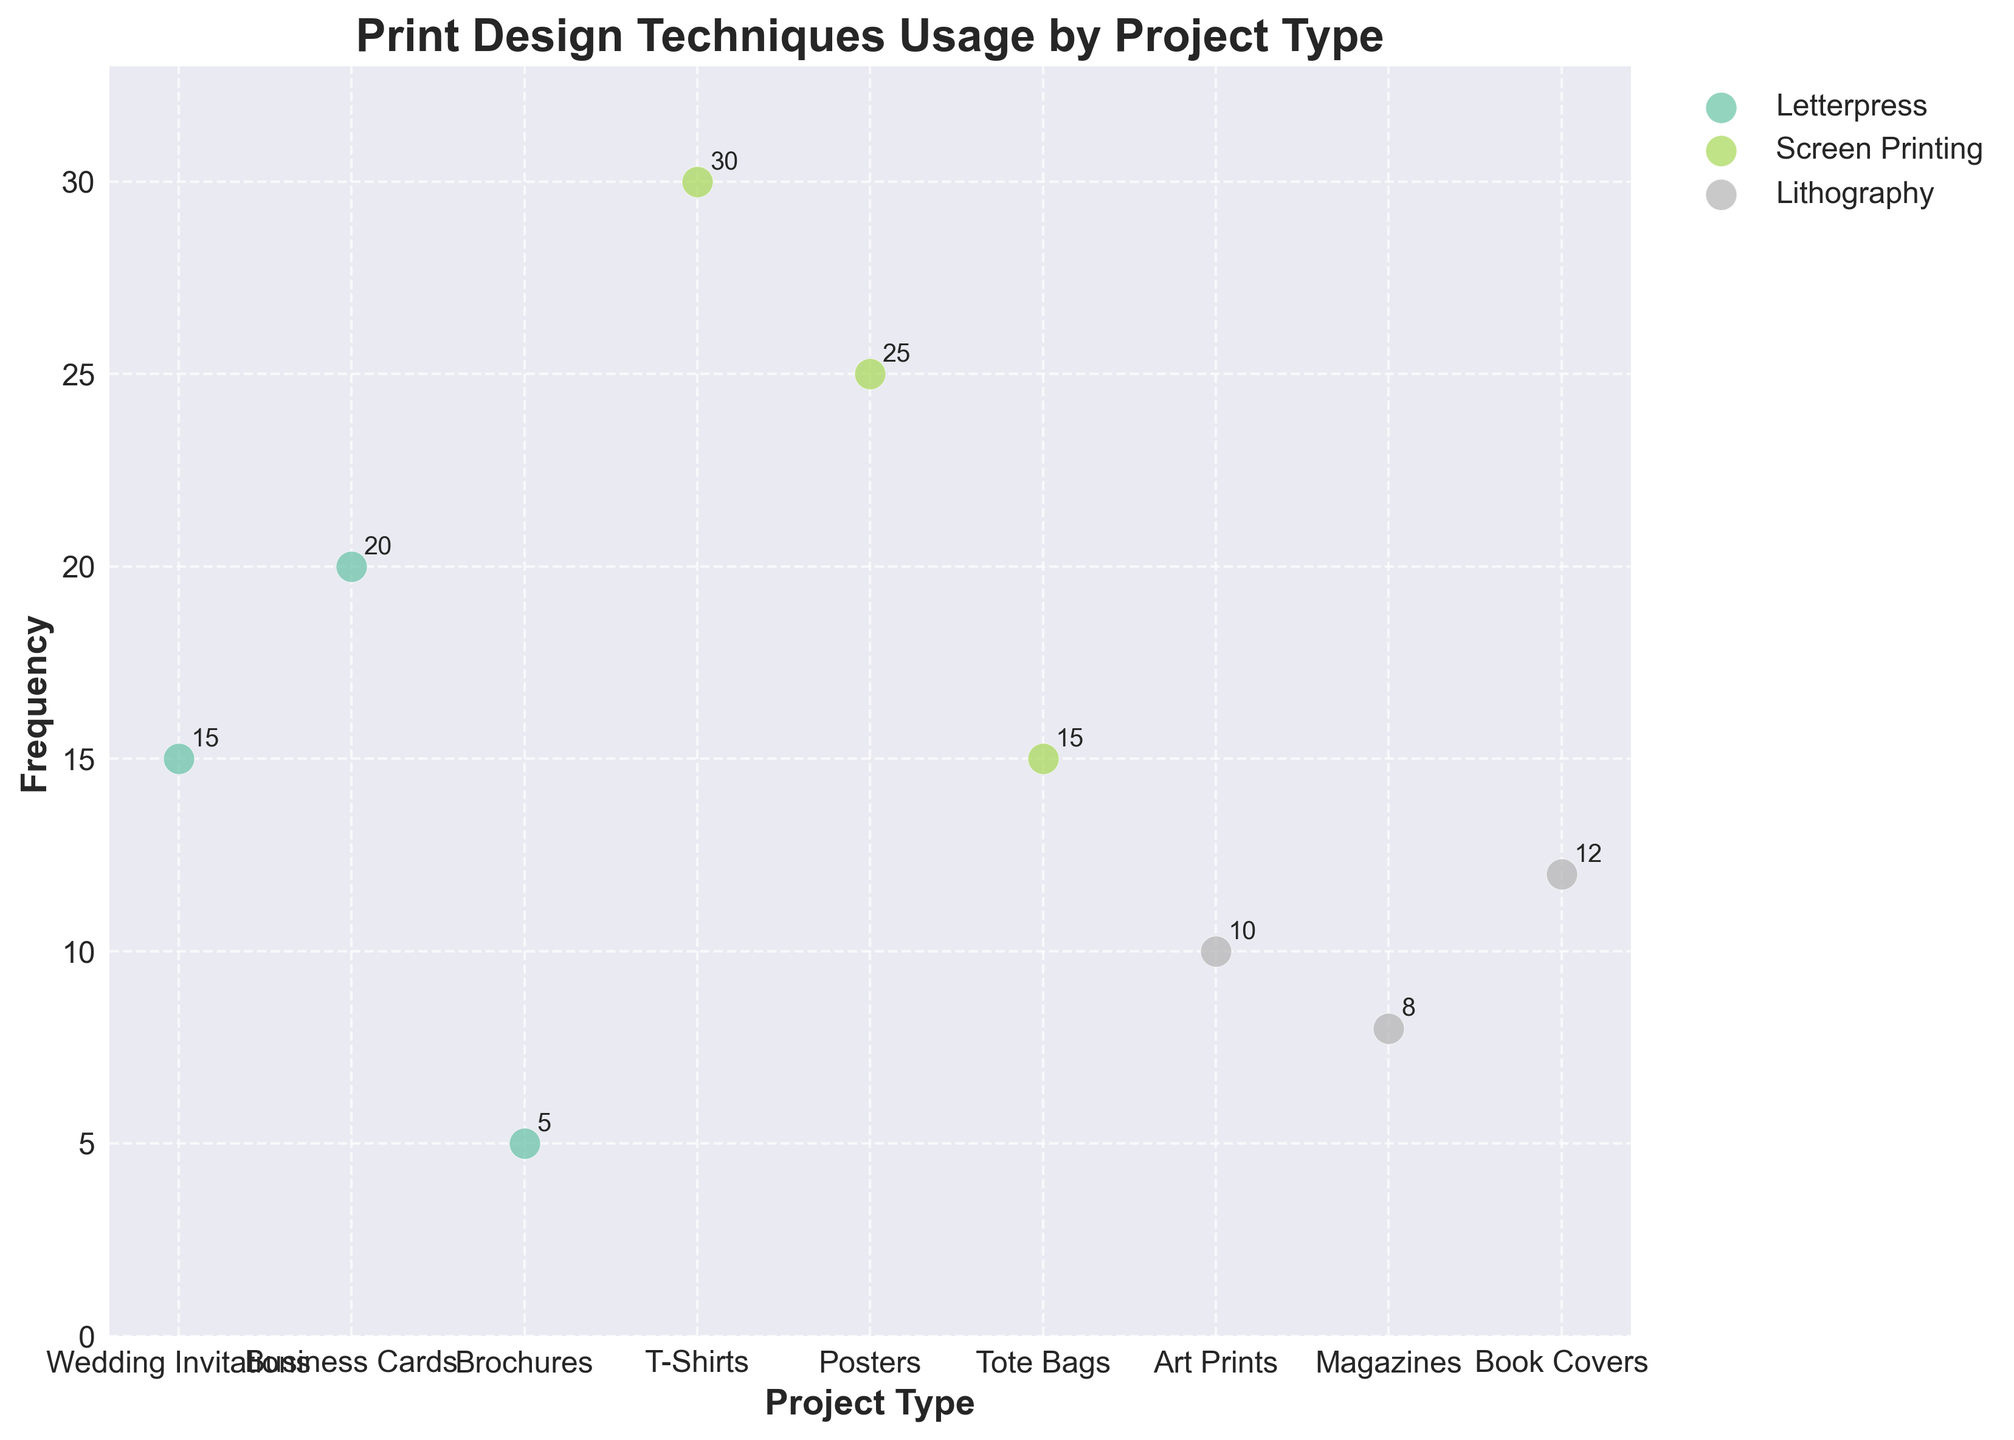What's the title of the plot? The title of the plot is displayed at the top and reads "Print Design Techniques Usage by Project Type."
Answer: Print Design Techniques Usage by Project Type What is the frequency of screen printing used for posters? Refer to the scatter plot and locate the data point labeled "Screen Printing" that corresponds to "Posters." The frequency indicated next to this point is 25.
Answer: 25 Which project type has the highest frequency for screen printing? Locate the "Screen Printing" label and identify the data point with the highest vertical position. This corresponds to "T-Shirts" with a frequency of 30.
Answer: T-Shirts What are the project types associated with letterpress technique? Locate all the data points labeled "Letterpress" and read the corresponding project types. They are "Wedding Invitations," "Business Cards," and "Brochures."
Answer: Wedding Invitations, Business Cards, Brochures What is the sum of frequencies for lithography projects? Identify the frequencies for "Lithography" from the scatter plot which are 10 (Art Prints), 8 (Magazines), and 12 (Book Covers). Calculate the sum: 10 + 8 + 12 = 30.
Answer: 30 Which technique is associated with the highest frequency for any project type? Compare the maximum frequency values for each technique. Screen Printing on T-Shirts has the highest frequency of 30.
Answer: Screen Printing What's the difference in frequency between screen printing on posters and letterpress on brochures? Find frequencies for screen printing on posters (25) and letterpress on brochures (5). Calculate the difference: 25 - 5 = 20.
Answer: 20 How many project types are associated with screen printing? Count the distinct project types associated with "Screen Printing" from the scatter plot, which are "T-Shirts," "Posters," and "Tote Bags."
Answer: 3 Which project type has the lowest frequency for letterpress technique? Among the "Letterpress" data points, identify the lowest frequency which is associated with "Brochures" at 5.
Answer: Brochures Is the frequency of lithography for book covers greater than for art prints? Check the frequencies for "Lithography" on "Book Covers" (12) and "Art Prints" (10). 12 is greater than 10.
Answer: Yes 